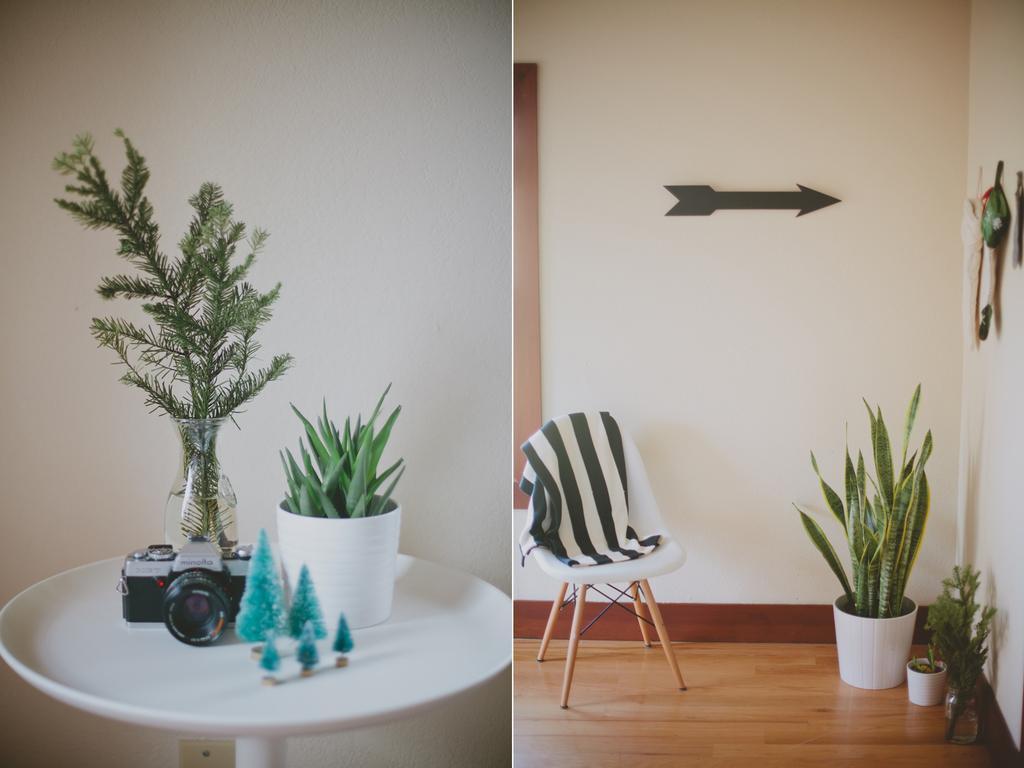Can you describe this image briefly? This is a collage. On the left side there is a table. And on the table there is a camera , flower vase containing some plants and also a pot with some other plants and toys are there. On the right side there is a chair and on the chair there is a towel and another pot with some plants. And on the wall there is an arrow mark. 